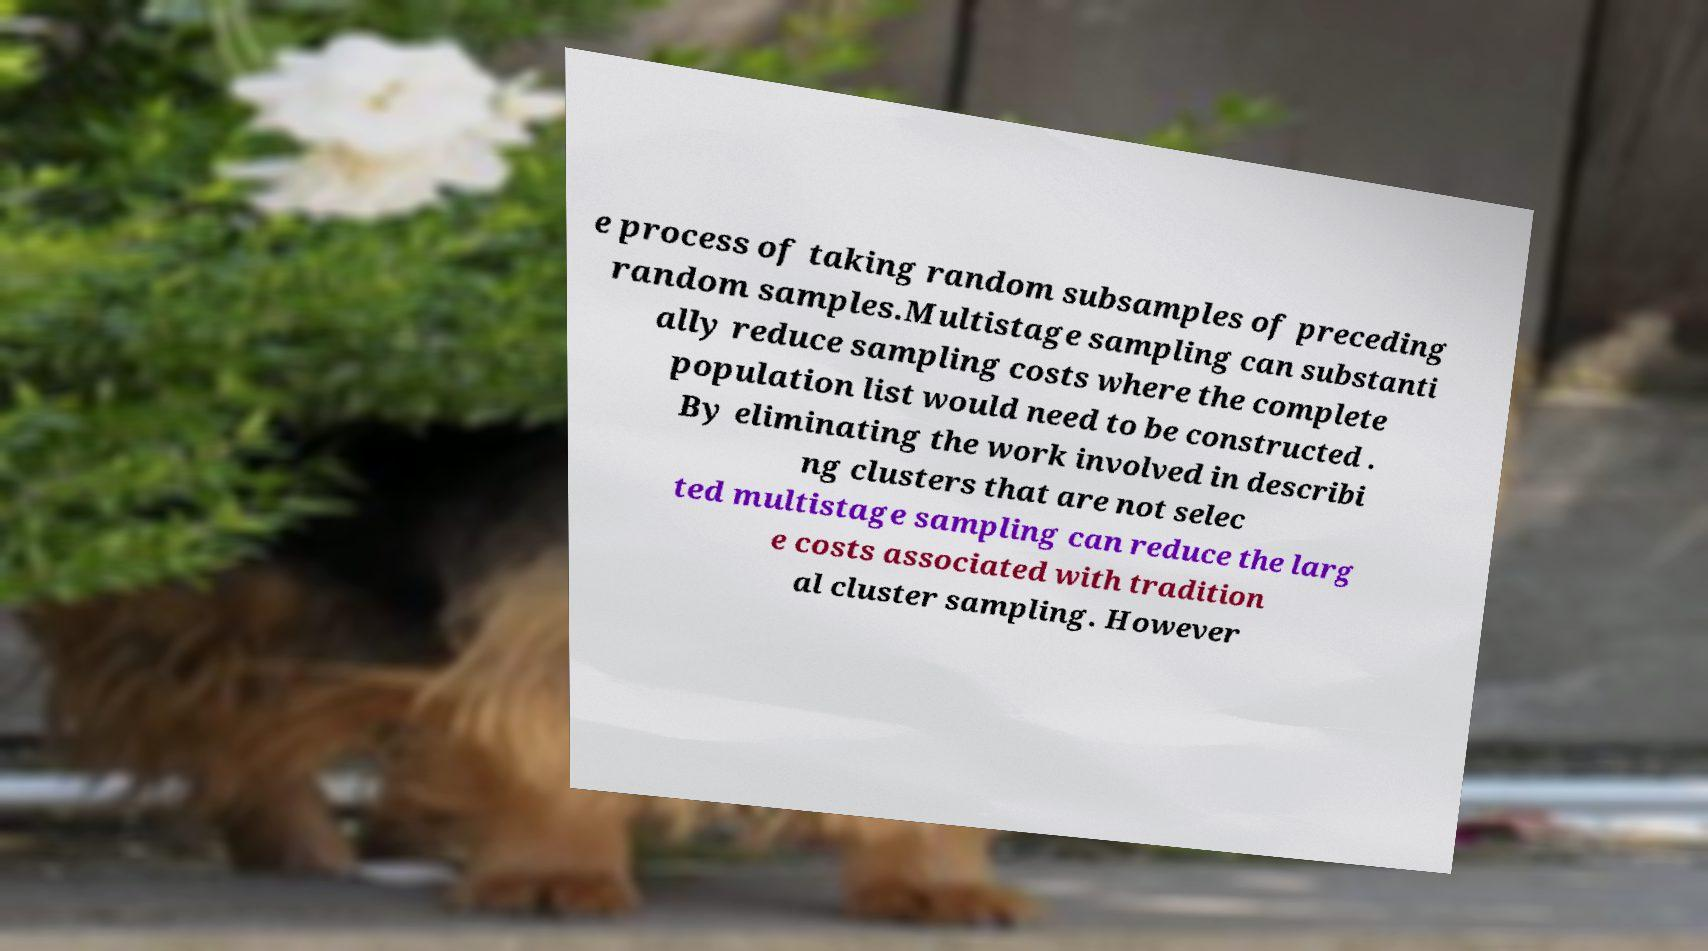Please identify and transcribe the text found in this image. e process of taking random subsamples of preceding random samples.Multistage sampling can substanti ally reduce sampling costs where the complete population list would need to be constructed . By eliminating the work involved in describi ng clusters that are not selec ted multistage sampling can reduce the larg e costs associated with tradition al cluster sampling. However 